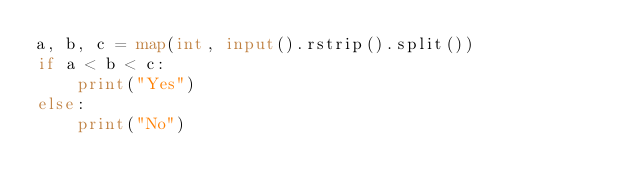<code> <loc_0><loc_0><loc_500><loc_500><_Python_>a, b, c = map(int, input().rstrip().split())
if a < b < c:
    print("Yes")
else:
    print("No")
    
</code> 